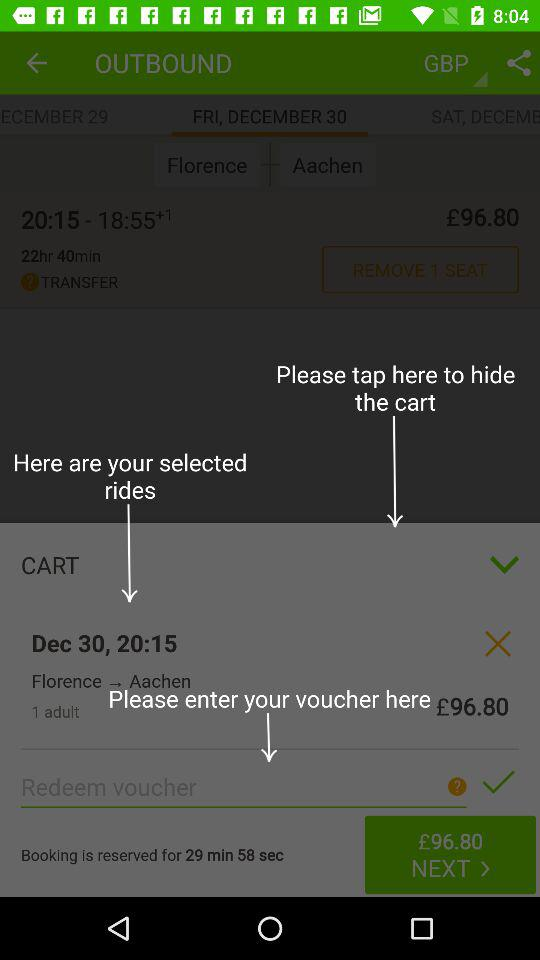What is the total amount in the cart? The total amount is £96.80. 